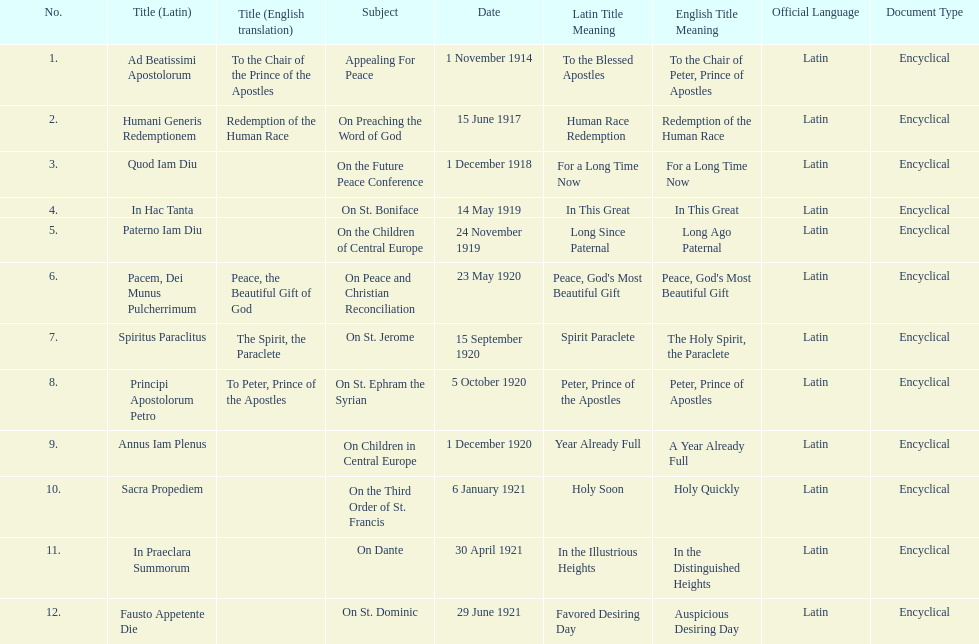How many titles are listed in the table? 12. 